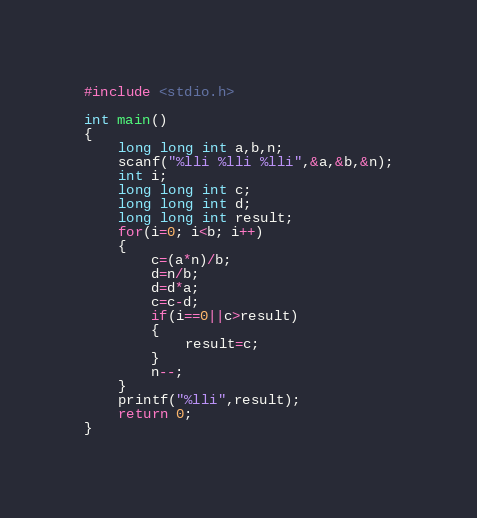Convert code to text. <code><loc_0><loc_0><loc_500><loc_500><_C_>#include <stdio.h>

int main()
{
    long long int a,b,n;
    scanf("%lli %lli %lli",&a,&b,&n);
    int i;
    long long int c;
    long long int d;
    long long int result;
    for(i=0; i<b; i++)
    {
        c=(a*n)/b;
        d=n/b;
        d=d*a;
        c=c-d;
        if(i==0||c>result)
        {
            result=c;
        }
        n--;
    }
    printf("%lli",result);
    return 0;
}
</code> 